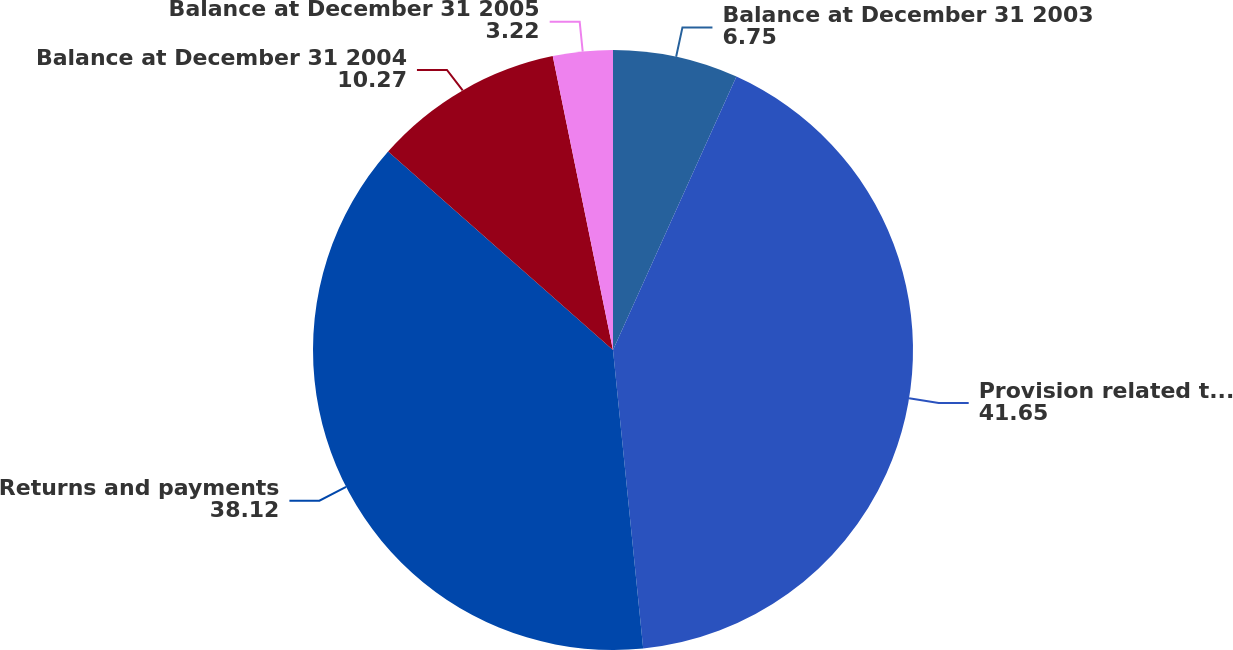Convert chart to OTSL. <chart><loc_0><loc_0><loc_500><loc_500><pie_chart><fcel>Balance at December 31 2003<fcel>Provision related to sales<fcel>Returns and payments<fcel>Balance at December 31 2004<fcel>Balance at December 31 2005<nl><fcel>6.75%<fcel>41.65%<fcel>38.12%<fcel>10.27%<fcel>3.22%<nl></chart> 